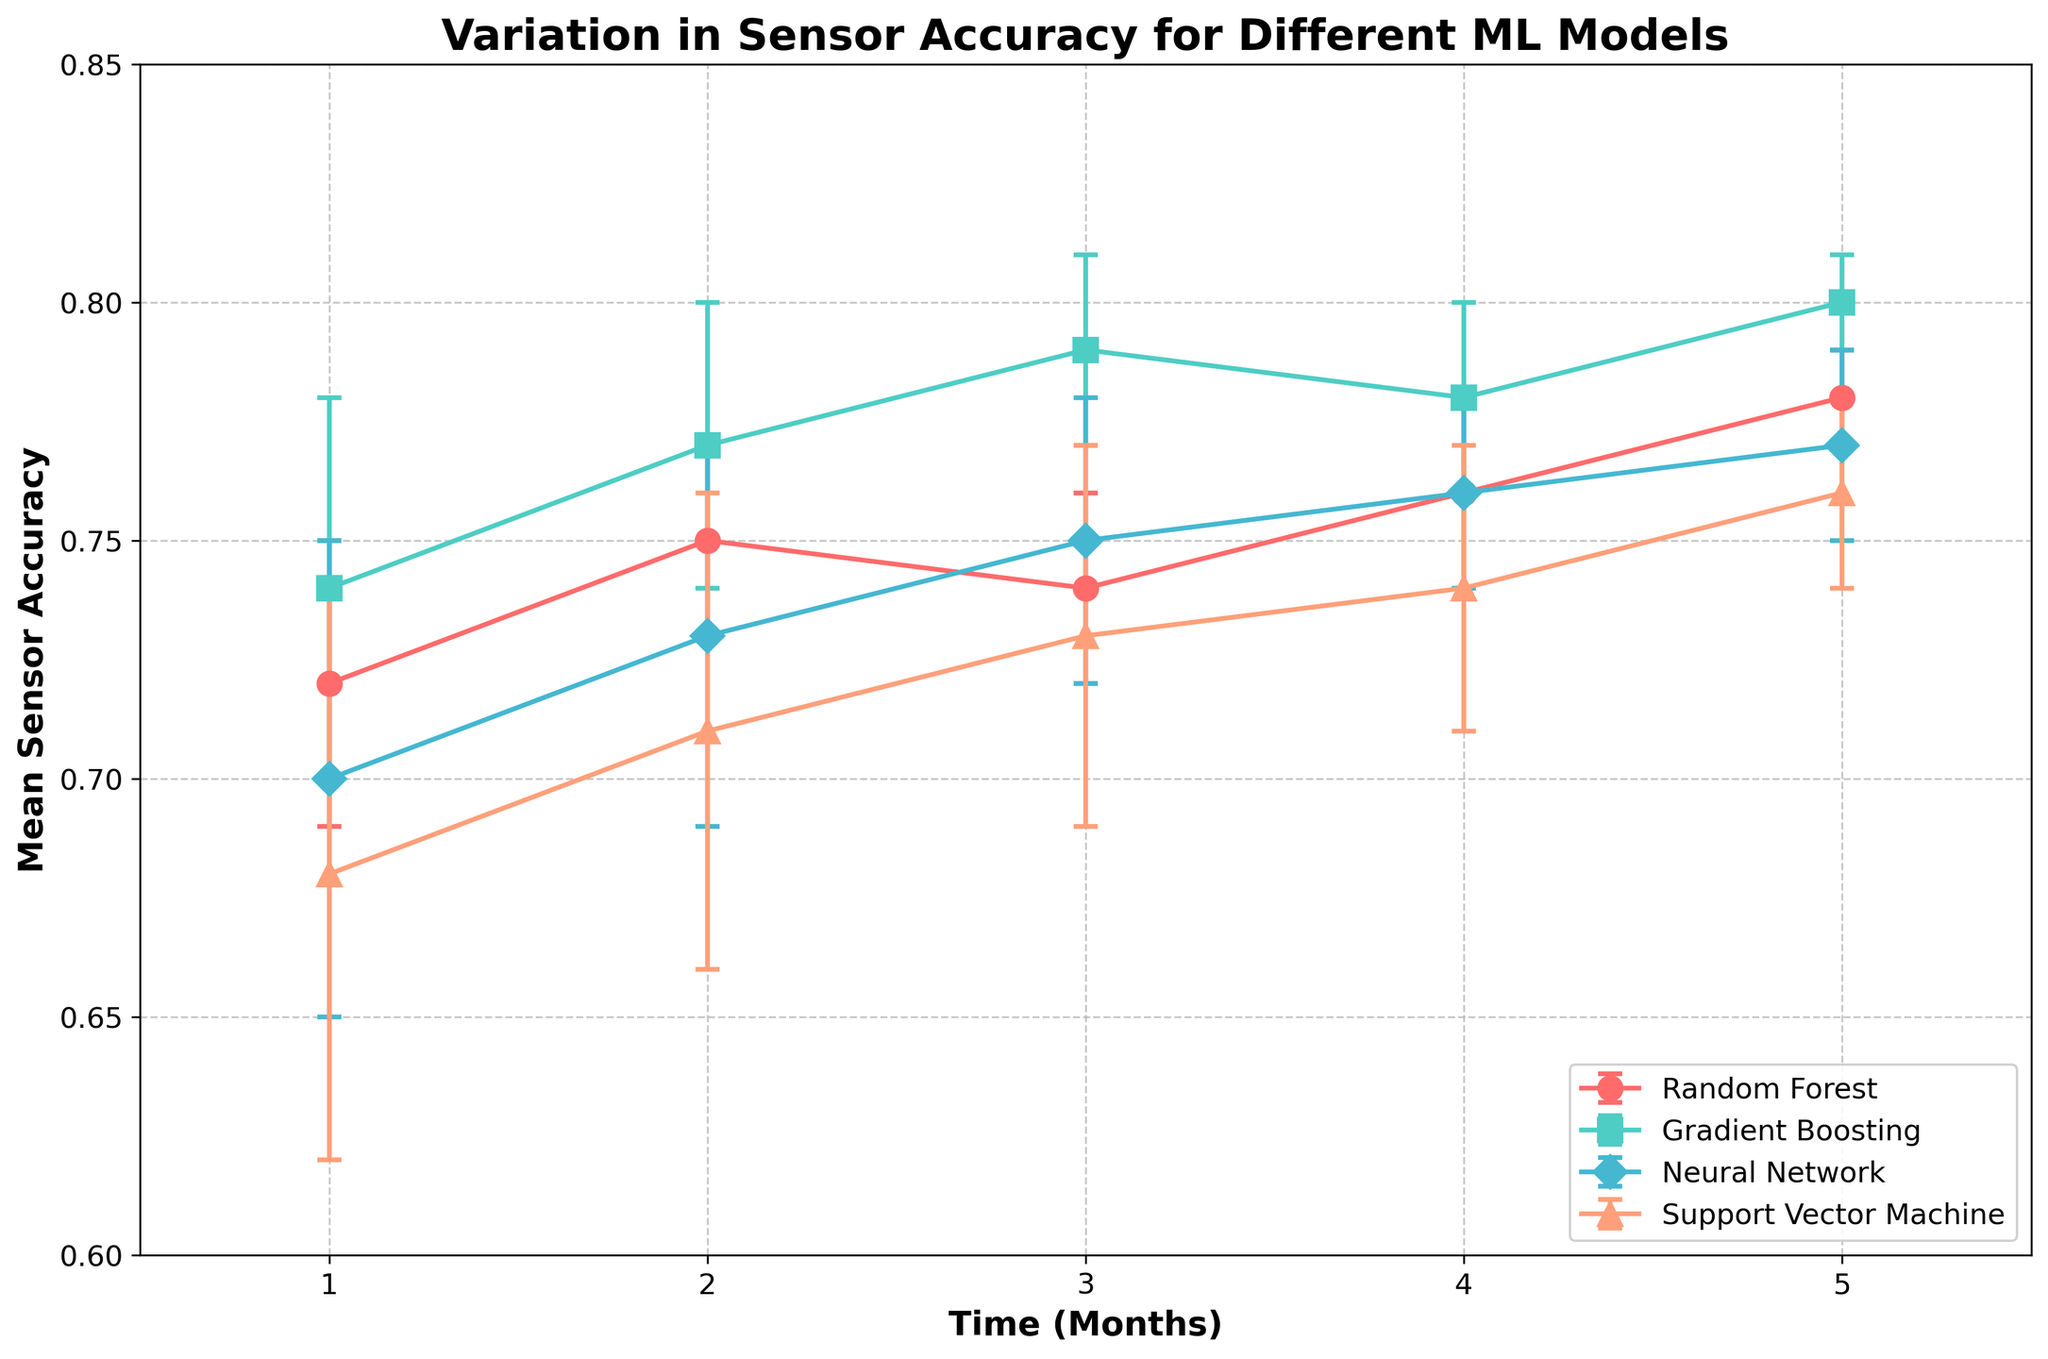What is the title of the plot? The title can be found at the top of the plot. It is typically larger and bolder compared to other text on the figure.
Answer: Variation in Sensor Accuracy for Different ML Models Which model shows the highest mean sensor accuracy at month 5? Look at the mean sensor accuracy values for each model at the 5-month mark on the x-axis. Identify the model with the highest value.
Answer: Gradient Boosting How does the sensor accuracy of the Random Forest model change from month 1 to month 5? Subtract the mean sensor accuracy at month 1 from that at month 5. (0.78 - 0.72)
Answer: It increases by 0.06 What is the range of sensor accuracy values for the Neural Network model at month 1? Identify the mean sensor accuracy and the error value at month 1 for the Neural Network model. Calculate the range using mean ± error. (0.70 ± 0.05)
Answer: 0.65 to 0.75 Which model has the largest error bar at any time point? Look at the length of the error bars for all models across all time points. Identify the model with the visibly largest error.
Answer: Support Vector Machine at month 1 What is the difference in mean sensor accuracy between the Gradient Boosting and Neural Network models at month 3? Subtract the mean sensor accuracies of the Neural Network from Gradient Boosting at month 3. (0.79 - 0.75)
Answer: 0.04 Out of the four models, which one shows the least variation in sensor accuracy over the 5 months? Examine the consistency of the sensor accuracy values for each model over time. Identify the model with the least fluctuation.
Answer: Random Forest At which month do the Gradient Boosting and Neural Network models have the same mean sensor accuracy? Check the mean sensor accuracy values for each month where the values are equal for both models.
Answer: Month 4 Which two models show the closest mean sensor accuracy at any month, and what is the mean sensor accuracy value for those months? Identify the months where the mean sensor accuracy values of two models are closest. Compare the differences and note the mean sensor accuracy value.
Answer: Random Forest and Neural Network at month 4, 0.76 